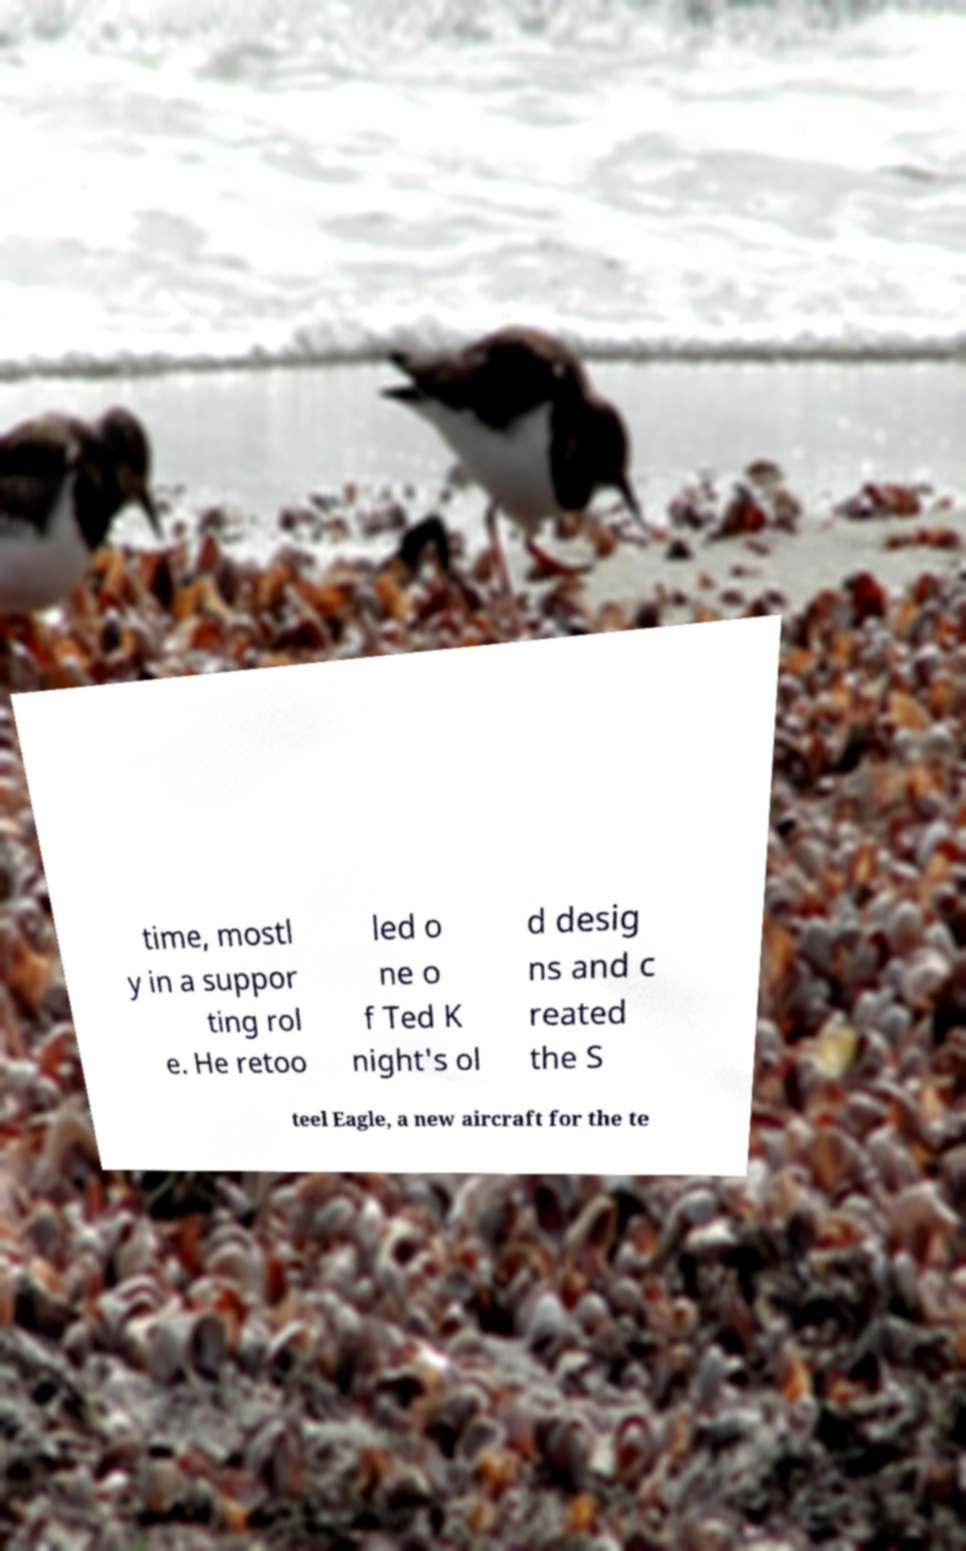There's text embedded in this image that I need extracted. Can you transcribe it verbatim? time, mostl y in a suppor ting rol e. He retoo led o ne o f Ted K night's ol d desig ns and c reated the S teel Eagle, a new aircraft for the te 